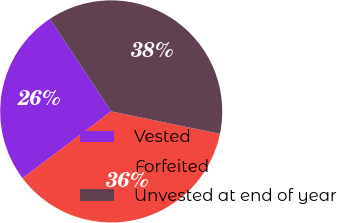Convert chart. <chart><loc_0><loc_0><loc_500><loc_500><pie_chart><fcel>Vested<fcel>Forfeited<fcel>Unvested at end of year<nl><fcel>25.98%<fcel>36.48%<fcel>37.54%<nl></chart> 